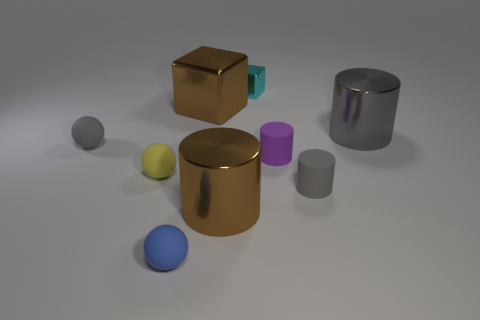What number of large objects are either brown cubes or brown objects?
Your answer should be very brief. 2. Are there any objects behind the tiny gray ball?
Your response must be concise. Yes. Are there an equal number of rubber things that are right of the purple cylinder and big metallic objects?
Your response must be concise. No. There is a brown metallic thing that is the same shape as the purple thing; what size is it?
Give a very brief answer. Large. There is a purple object; does it have the same shape as the brown metallic object in front of the small gray matte sphere?
Give a very brief answer. Yes. There is a gray matte thing that is left of the big brown metal object that is behind the tiny purple cylinder; what size is it?
Provide a succinct answer. Small. Are there the same number of tiny cyan blocks to the left of the blue rubber sphere and cyan shiny things that are in front of the brown cylinder?
Give a very brief answer. Yes. What is the color of the other shiny thing that is the same shape as the big gray shiny thing?
Provide a short and direct response. Brown. What number of big cylinders have the same color as the big block?
Your response must be concise. 1. There is a tiny gray matte thing that is left of the brown block; does it have the same shape as the yellow matte thing?
Offer a terse response. Yes. 